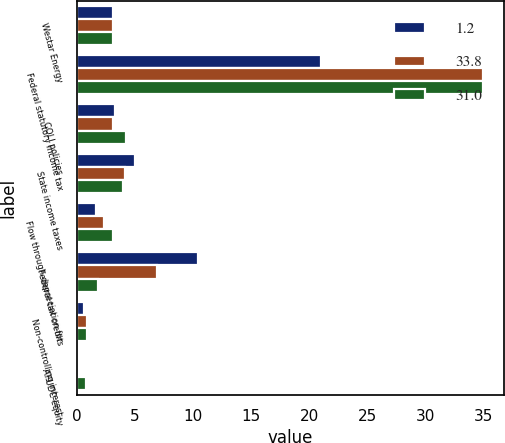Convert chart to OTSL. <chart><loc_0><loc_0><loc_500><loc_500><stacked_bar_chart><ecel><fcel>Westar Energy<fcel>Federal statutory income tax<fcel>COLI policies<fcel>State income taxes<fcel>Flow through depreciation for<fcel>Federal tax credits<fcel>Non-controlling interest<fcel>AFUDC equity<nl><fcel>1.2<fcel>3.1<fcel>21<fcel>3.3<fcel>5<fcel>1.6<fcel>10.4<fcel>0.6<fcel>0.2<nl><fcel>33.8<fcel>3.1<fcel>35<fcel>3.1<fcel>4.1<fcel>2.3<fcel>6.9<fcel>0.9<fcel>0.2<nl><fcel>31<fcel>3.1<fcel>35<fcel>4.2<fcel>4<fcel>3.1<fcel>1.8<fcel>0.9<fcel>0.8<nl></chart> 